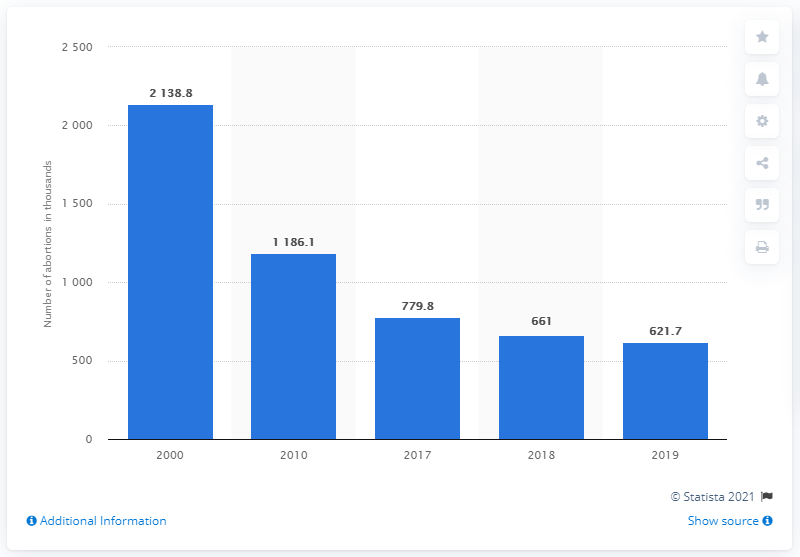Point out several critical features in this image. In 2000, over 2.1 million abortions were recorded in Russia. 